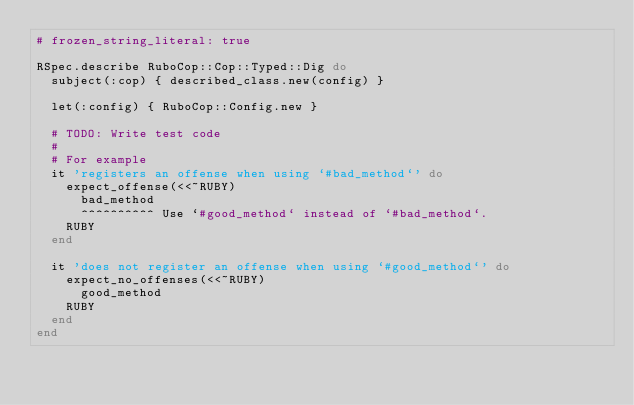<code> <loc_0><loc_0><loc_500><loc_500><_Ruby_># frozen_string_literal: true

RSpec.describe RuboCop::Cop::Typed::Dig do
  subject(:cop) { described_class.new(config) }

  let(:config) { RuboCop::Config.new }

  # TODO: Write test code
  #
  # For example
  it 'registers an offense when using `#bad_method`' do
    expect_offense(<<~RUBY)
      bad_method
      ^^^^^^^^^^ Use `#good_method` instead of `#bad_method`.
    RUBY
  end

  it 'does not register an offense when using `#good_method`' do
    expect_no_offenses(<<~RUBY)
      good_method
    RUBY
  end
end
</code> 